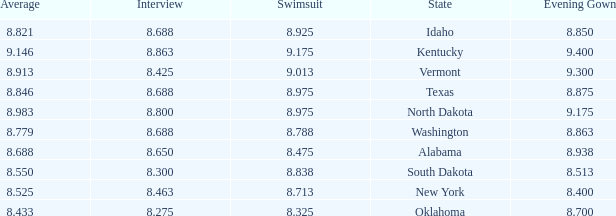What is the lowest evening score of the contestant with an evening gown less than 8.938, from Texas, and with an average less than 8.846 has? None. Parse the full table. {'header': ['Average', 'Interview', 'Swimsuit', 'State', 'Evening Gown'], 'rows': [['8.821', '8.688', '8.925', 'Idaho', '8.850'], ['9.146', '8.863', '9.175', 'Kentucky', '9.400'], ['8.913', '8.425', '9.013', 'Vermont', '9.300'], ['8.846', '8.688', '8.975', 'Texas', '8.875'], ['8.983', '8.800', '8.975', 'North Dakota', '9.175'], ['8.779', '8.688', '8.788', 'Washington', '8.863'], ['8.688', '8.650', '8.475', 'Alabama', '8.938'], ['8.550', '8.300', '8.838', 'South Dakota', '8.513'], ['8.525', '8.463', '8.713', 'New York', '8.400'], ['8.433', '8.275', '8.325', 'Oklahoma', '8.700']]} 